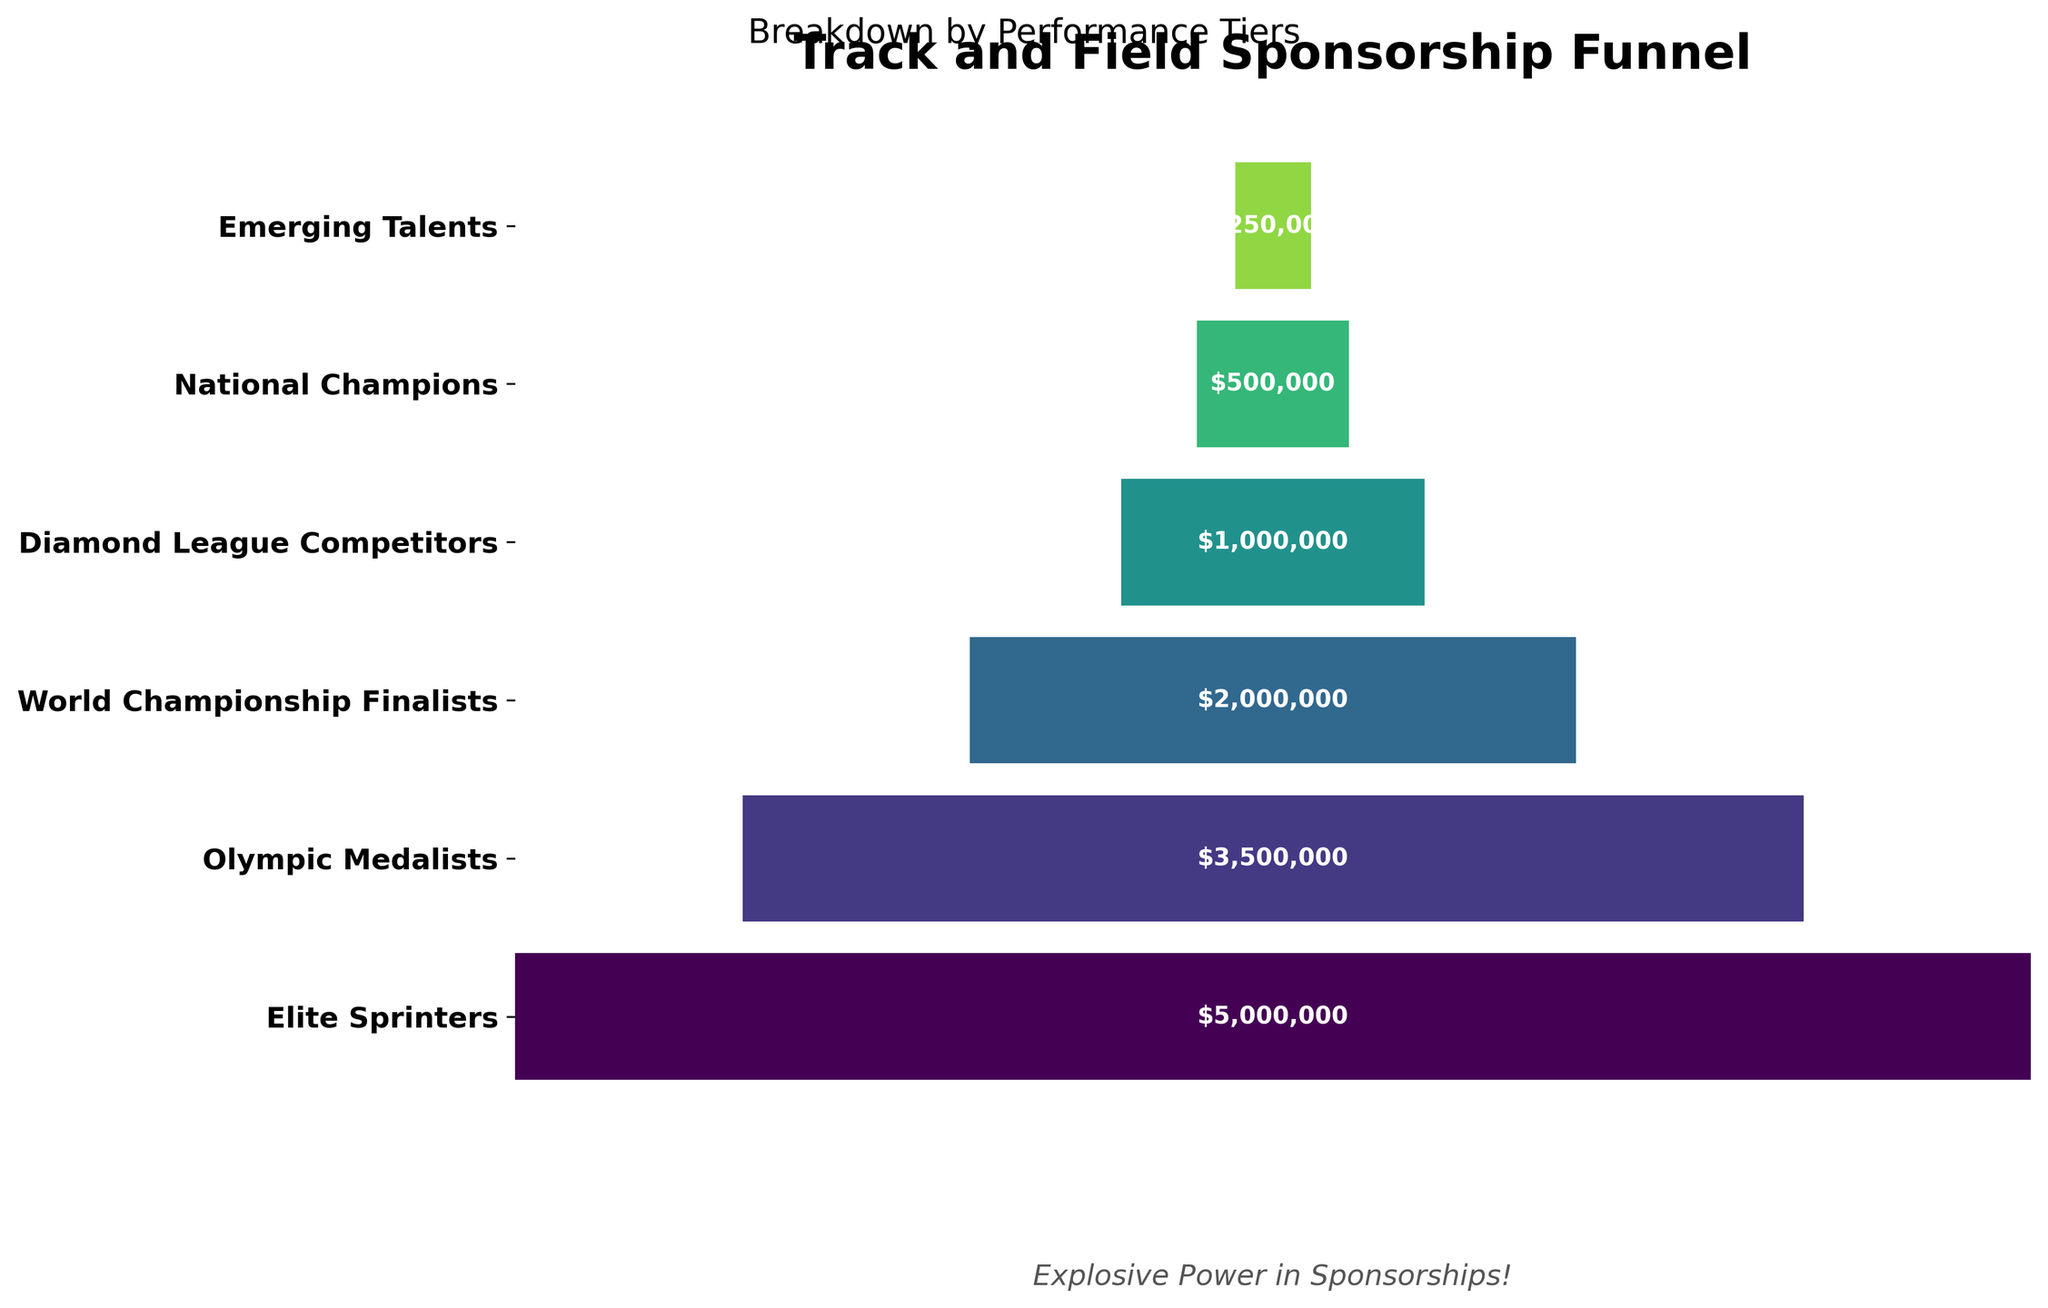What is the title of the chart? The title of the chart is located at the top and serves to explain the main topic of the visual representation. The title of this chart is "Track and Field Sponsorship Funnel".
Answer: Track and Field Sponsorship Funnel How many performance tiers are illustrated in the chart? By counting the distinct categories listed on the y-axis, we can determine the number of performance tiers in the chart. There are six tiers illustrated.
Answer: Six Which tier of athletes has the highest sponsorship value? The width of the bars represents the sponsorship value. The widest bar, indicating the highest value, belongs to the "Elite Sprinters" tier.
Answer: Elite Sprinters What is the total sponsorship value for the top three performance tiers combined? To find the total value, we sum the sponsorship values of the top three tiers: Elite Sprinters ($5,000,000), Olympic Medalists ($3,500,000), and World Championship Finalists ($2,000,000). The total is $5,000,000 + $3,500,000 + $2,000,000 = $10,500,000.
Answer: $10,500,000 How does the sponsorship value of National Champions compare to that of Emerging Talents? We compare the values by looking at the bar lengths. National Champions have a sponsorship value of $500,000, while Emerging Talents have $250,000. National Champions have exactly double the sponsorship value of Emerging Talents.
Answer: Double Which category has the smallest sponsorship value, and what is that value? By identifying the narrowest bar, we see that "Emerging Talents" has the smallest sponsorship value at $250,000.
Answer: Emerging Talents, $250,000 What is the approximate difference in sponsorship value between Olympic Medalists and Diamond League Competitors? Subtract the sponsorship value of Diamond League Competitors ($1,000,000) from that of Olympic Medalists ($3,500,000): $3,500,000 - $1,000,000 = $2,500,000.
Answer: $2,500,000 What's the average sponsorship value across all performance tiers? First, sum all sponsorship values: $5,000,000 (Elite Sprinters) + $3,500,000 (Olympic Medalists) + $2,000,000 (World Championship Finalists) + $1,000,000 (Diamond League Competitors) + $500,000 (National Champions) + $250,000 (Emerging Talents) = $12,250,000. Then divide by the number of tiers (6): $12,250,000 / 6 = $2,041,667 (approx).
Answer: $2,041,667 What percentage of the total sponsorship value does the Elite Sprinters category represent? To find the percentage, divide the sponsorship value of Elite Sprinters by the total value and multiply by 100: ($5,000,000 / $12,250,000) * 100 ≈ 40.82%.
Answer: 40.82% How many sponsorship value labels are displayed on the chart? Each performance tier has a sponsorship value labeled on the chart. Since there are six tiers, there are six value labels.
Answer: Six 